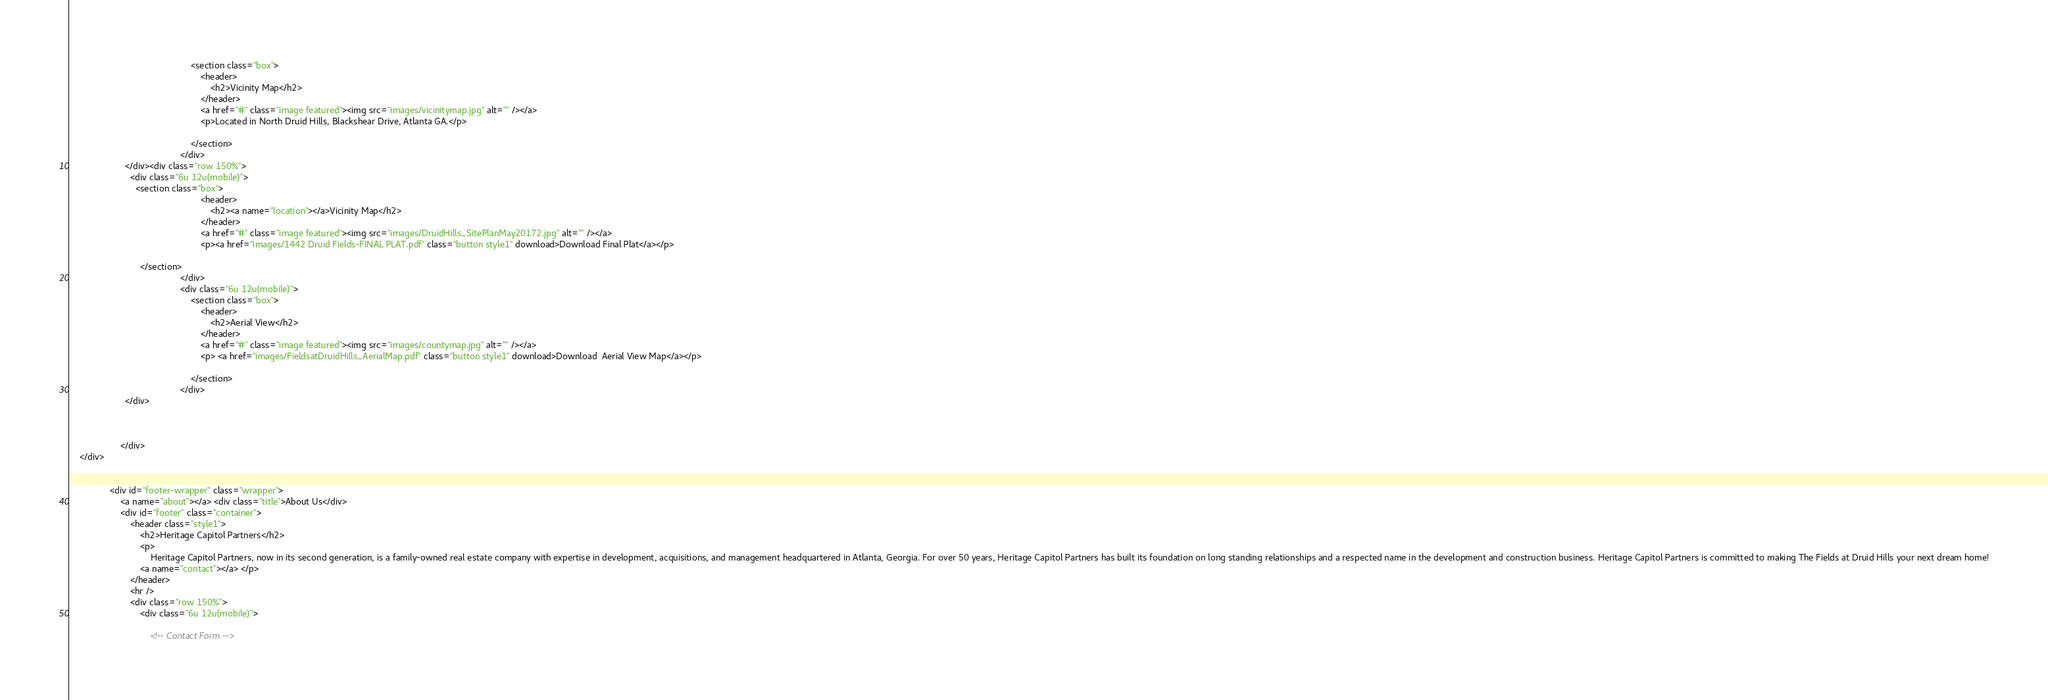Convert code to text. <code><loc_0><loc_0><loc_500><loc_500><_HTML_>												<section class="box">
													<header>
														<h2>Vicinity Map</h2>
													</header>
													<a href="#" class="image featured"><img src="images/vicinitymap.jpg" alt="" /></a>
													<p>Located in North Druid Hills, Blackshear Drive, Atlanta GA.</p>
													
												</section>
											</div>
					  </div><div class="row 150%">
						<div class="6u 12u(mobile)">
						  <section class="box">
													<header>
														<h2><a name="location"></a>Vicinity Map</h2>
													</header>
													<a href="#" class="image featured"><img src="images/DruidHills_SitePlanMay20172.jpg" alt="" /></a>
													<p><a href="images/1442 Druid Fields-FINAL PLAT.pdf" class="button style1" download>Download Final Plat</a></p>
													
							</section>
											</div>
											<div class="6u 12u(mobile)">
												<section class="box">
													<header>
														<h2>Aerial View</h2>
													</header>
													<a href="#" class="image featured"><img src="images/countymap.jpg" alt="" /></a>
													<p> <a href="images/FieldsatDruidHills_AerialMap.pdf" class="button style1" download>Download  Aerial View Map</a></p>
													
												</section>
											</div>
					  </div>
					

						
					</div>
	</div>
    
		
				<div id="footer-wrapper" class="wrapper">
					<a name="about"></a> <div class="title">About Us</div>
					<div id="footer" class="container">
						<header class="style1">
							<h2>Heritage Capitol Partners</h2>
							<p>
								Heritage Capitol Partners, now in its second generation, is a family-owned real estate company with expertise in development, acquisitions, and management headquartered in Atlanta, Georgia. For over 50 years, Heritage Capitol Partners has built its foundation on long standing relationships and a respected name in the development and construction business. Heritage Capitol Partners is committed to making The Fields at Druid Hills your next dream home!
							<a name="contact"></a> </p>
						</header>
						<hr />
						<div class="row 150%">
							<div class="6u 12u(mobile)">

								<!-- Contact Form --></code> 